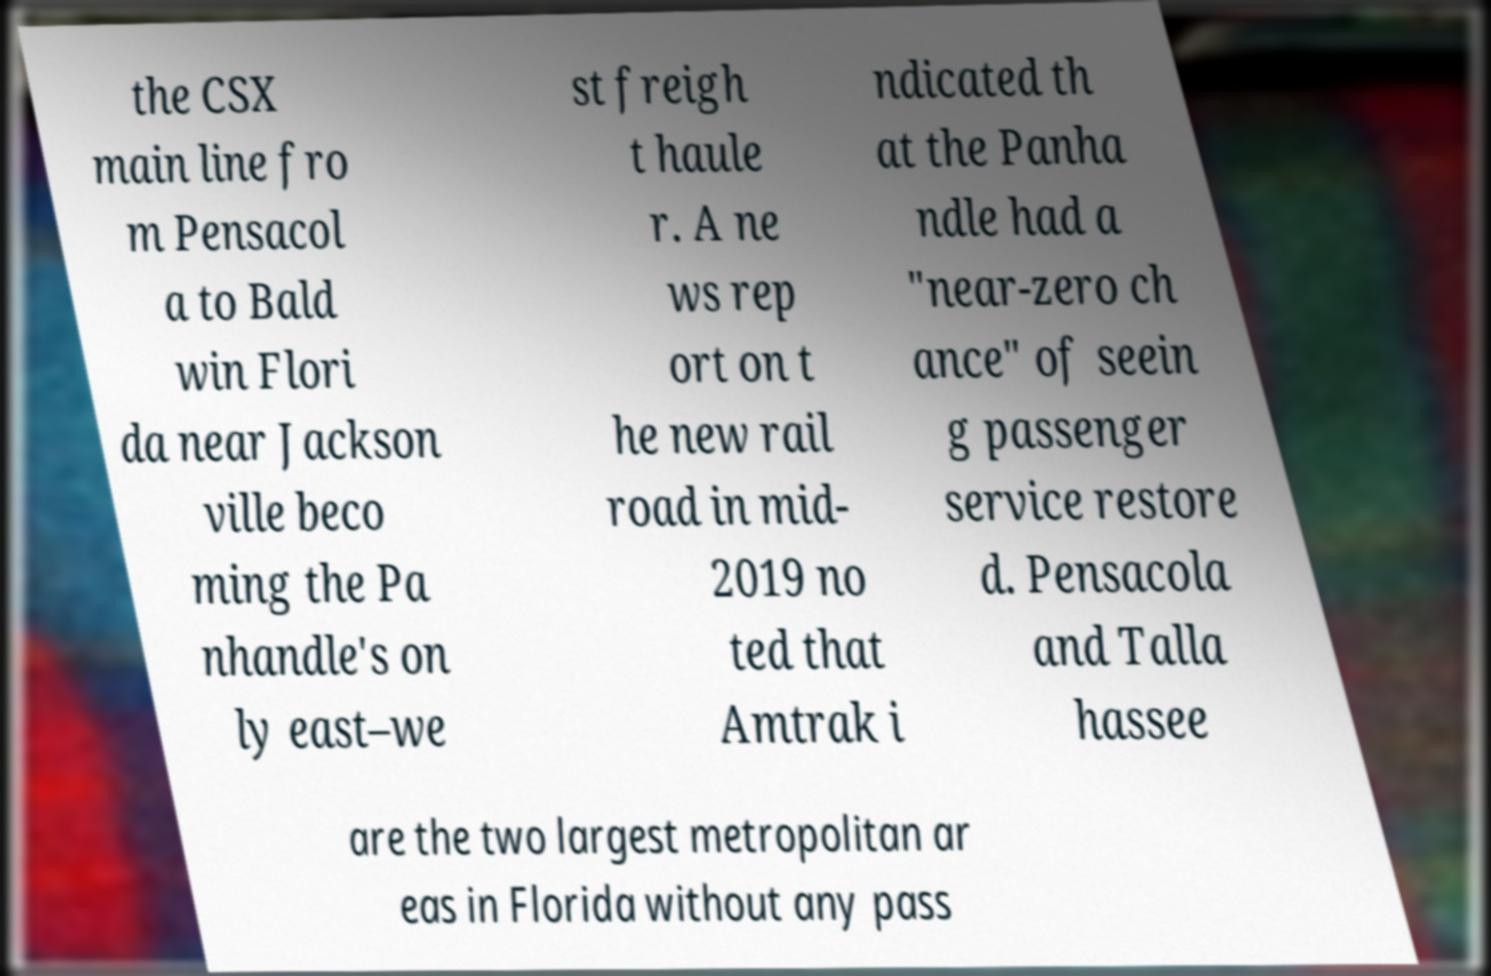I need the written content from this picture converted into text. Can you do that? the CSX main line fro m Pensacol a to Bald win Flori da near Jackson ville beco ming the Pa nhandle's on ly east–we st freigh t haule r. A ne ws rep ort on t he new rail road in mid- 2019 no ted that Amtrak i ndicated th at the Panha ndle had a "near-zero ch ance" of seein g passenger service restore d. Pensacola and Talla hassee are the two largest metropolitan ar eas in Florida without any pass 